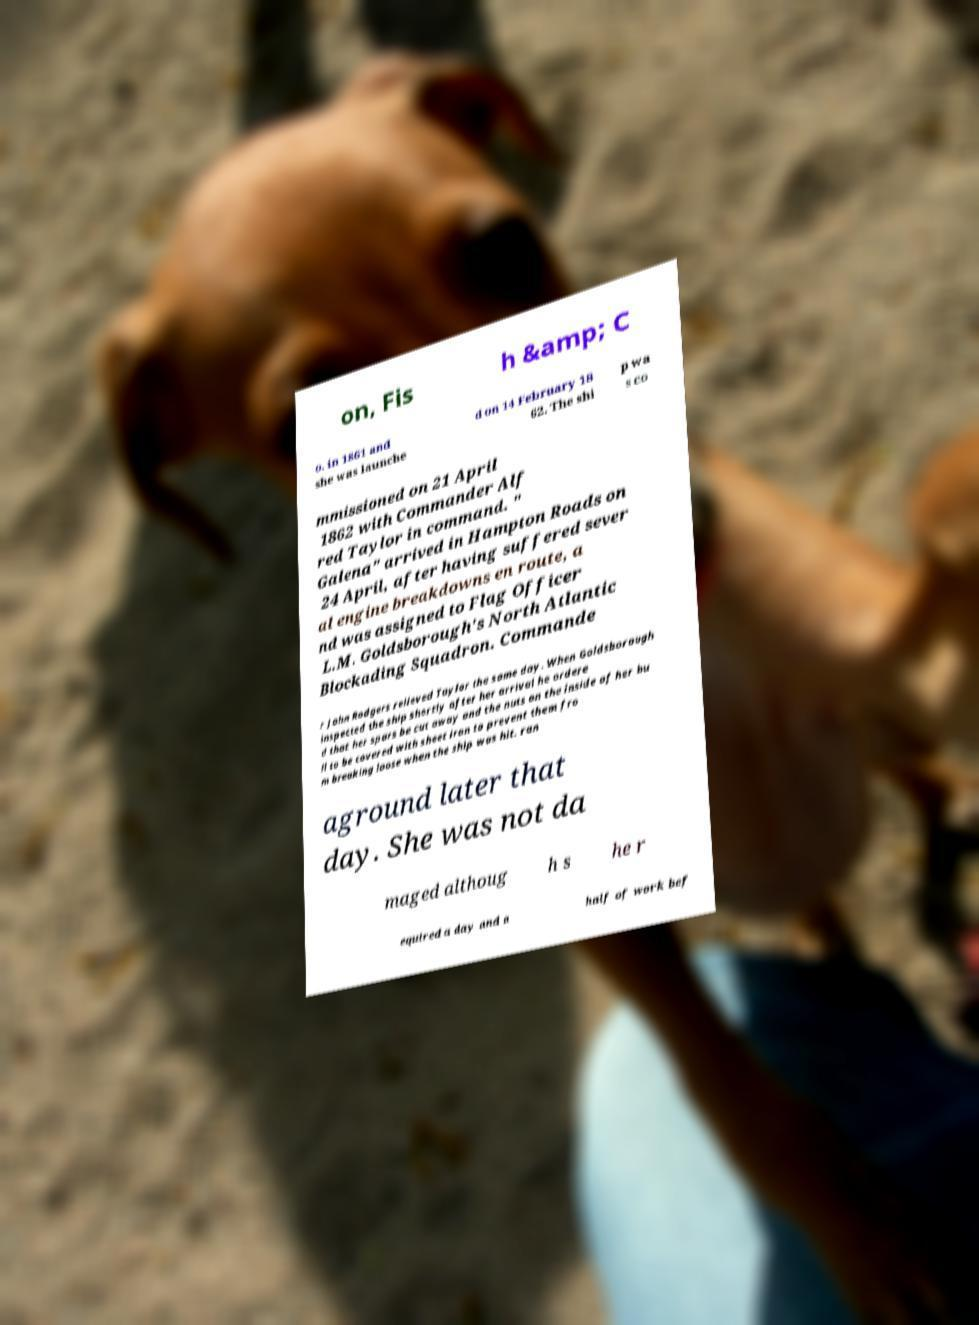Can you read and provide the text displayed in the image?This photo seems to have some interesting text. Can you extract and type it out for me? on, Fis h &amp; C o. in 1861 and she was launche d on 14 February 18 62. The shi p wa s co mmissioned on 21 April 1862 with Commander Alf red Taylor in command. " Galena" arrived in Hampton Roads on 24 April, after having suffered sever al engine breakdowns en route, a nd was assigned to Flag Officer L.M. Goldsborough's North Atlantic Blockading Squadron. Commande r John Rodgers relieved Taylor the same day. When Goldsborough inspected the ship shortly after her arrival he ordere d that her spars be cut away and the nuts on the inside of her hu ll to be covered with sheet iron to prevent them fro m breaking loose when the ship was hit. ran aground later that day. She was not da maged althoug h s he r equired a day and a half of work bef 